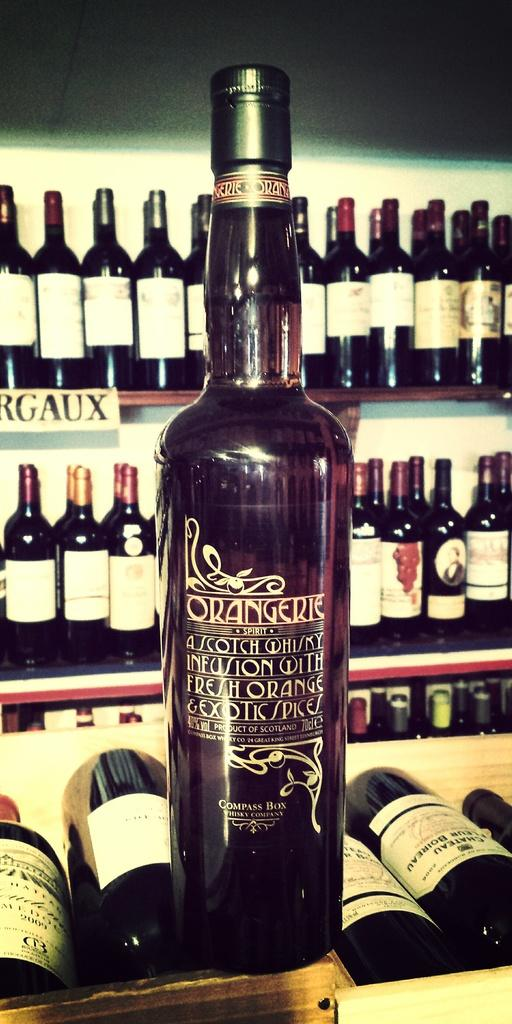Provide a one-sentence caption for the provided image. Bottles of foreign made alcohol are out on display. 